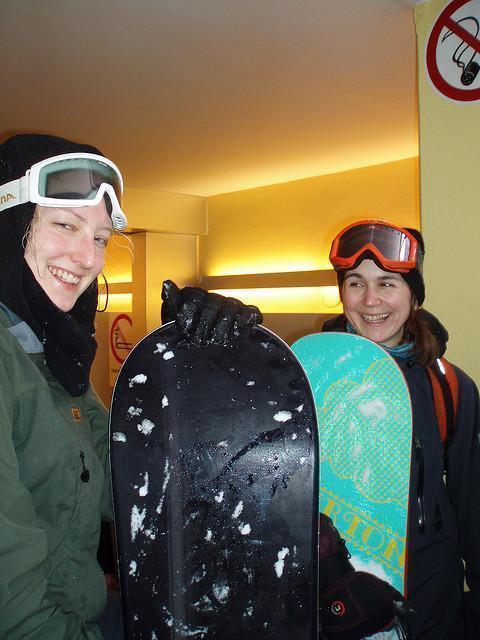What can't be done in this room?
Select the correct answer and articulate reasoning with the following format: 'Answer: answer
Rationale: rationale.'
Options: Drinking, smoking, dancing, talking. Answer: smoking.
Rationale: A sign showing a cigarette with a line through it is on the wall. 